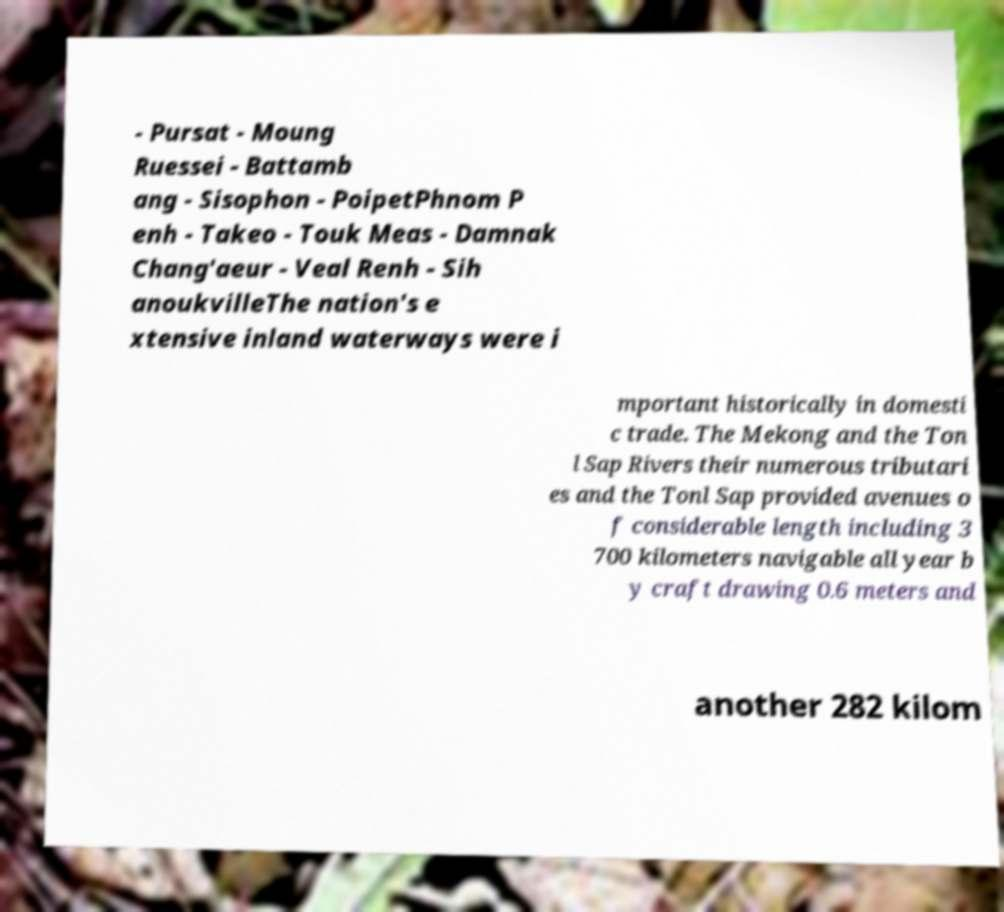Please identify and transcribe the text found in this image. - Pursat - Moung Ruessei - Battamb ang - Sisophon - PoipetPhnom P enh - Takeo - Touk Meas - Damnak Chang'aeur - Veal Renh - Sih anoukvilleThe nation's e xtensive inland waterways were i mportant historically in domesti c trade. The Mekong and the Ton l Sap Rivers their numerous tributari es and the Tonl Sap provided avenues o f considerable length including 3 700 kilometers navigable all year b y craft drawing 0.6 meters and another 282 kilom 